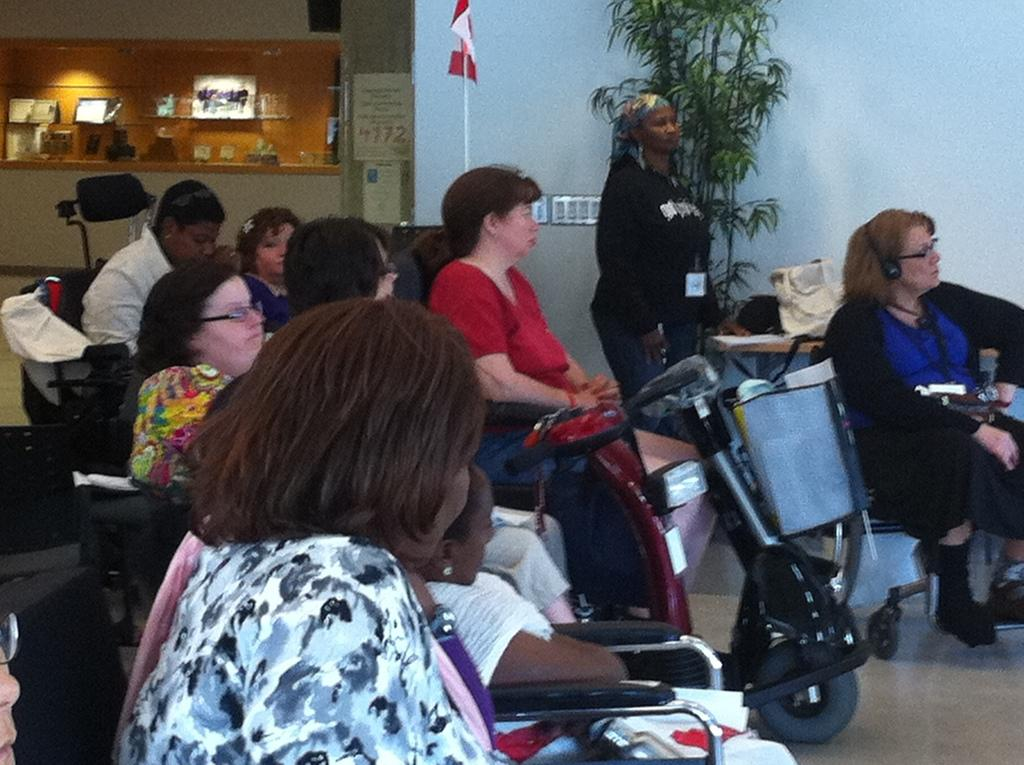What are the people in the image doing? The people in the image are sitting. Is there anyone standing in the image? Yes, there is a person standing in the image. What can be seen besides people in the image? There is a plant and a flag in the image. What is the color of the wall in the image? The wall in the image is white. What type of potato is being peeled by the person standing in the image? There is no potato present in the image, and therefore no potato peeling activity can be observed. 